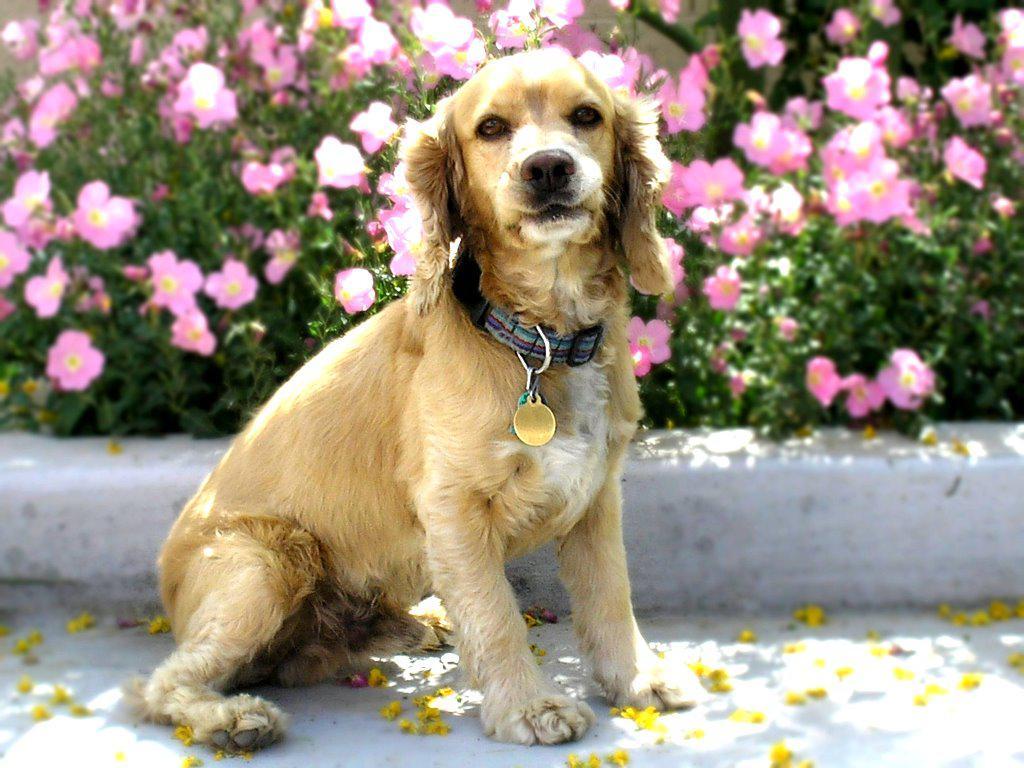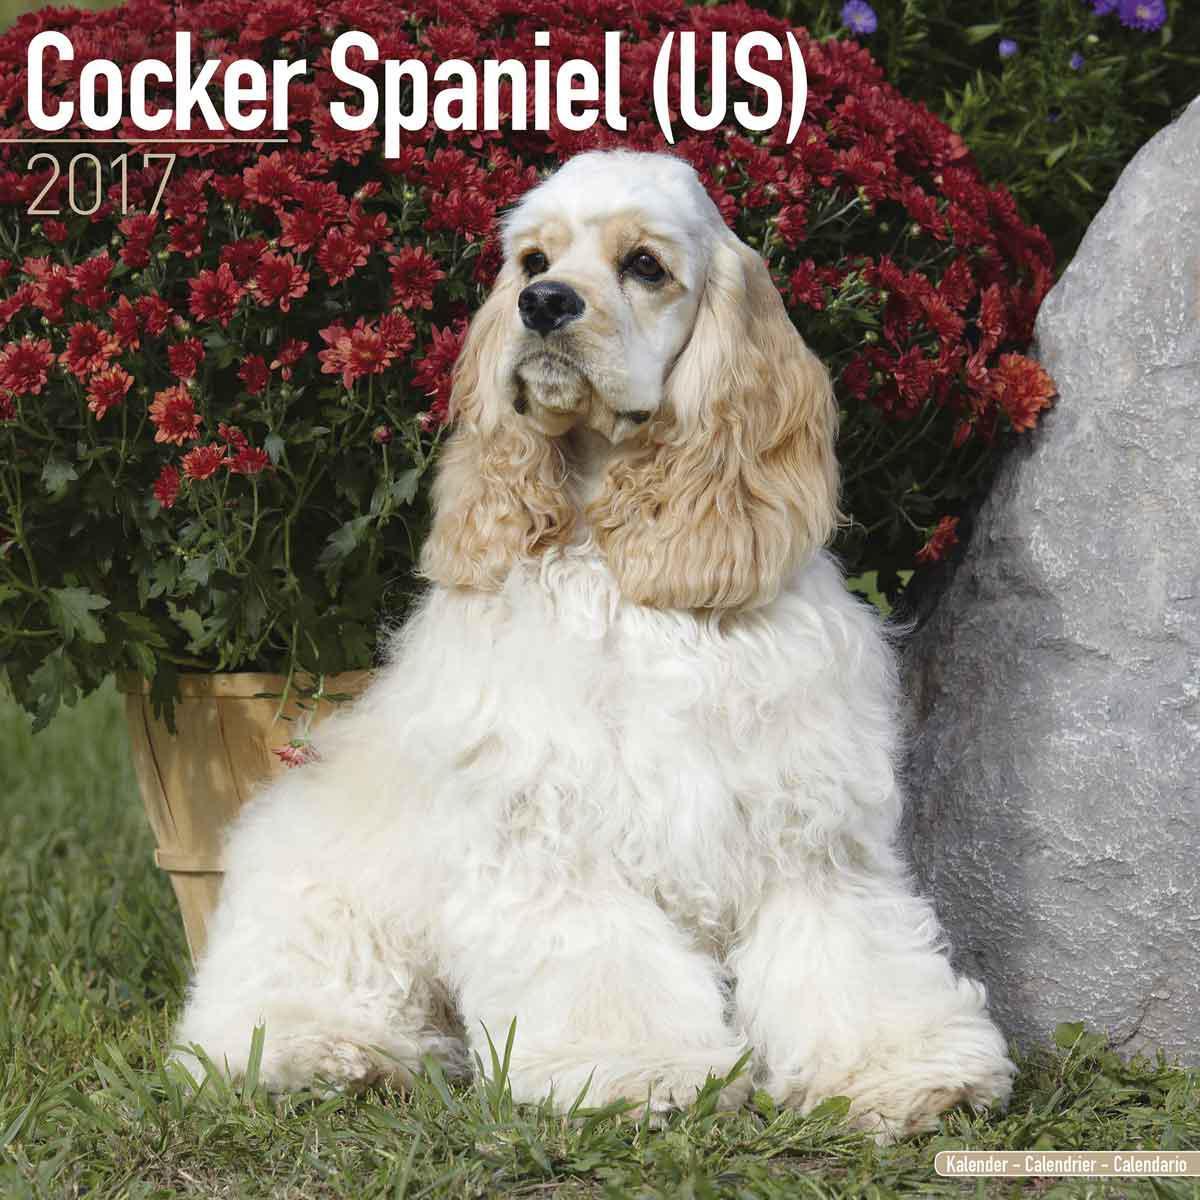The first image is the image on the left, the second image is the image on the right. Assess this claim about the two images: "A person is tending to the dog in one of the images.". Correct or not? Answer yes or no. No. 